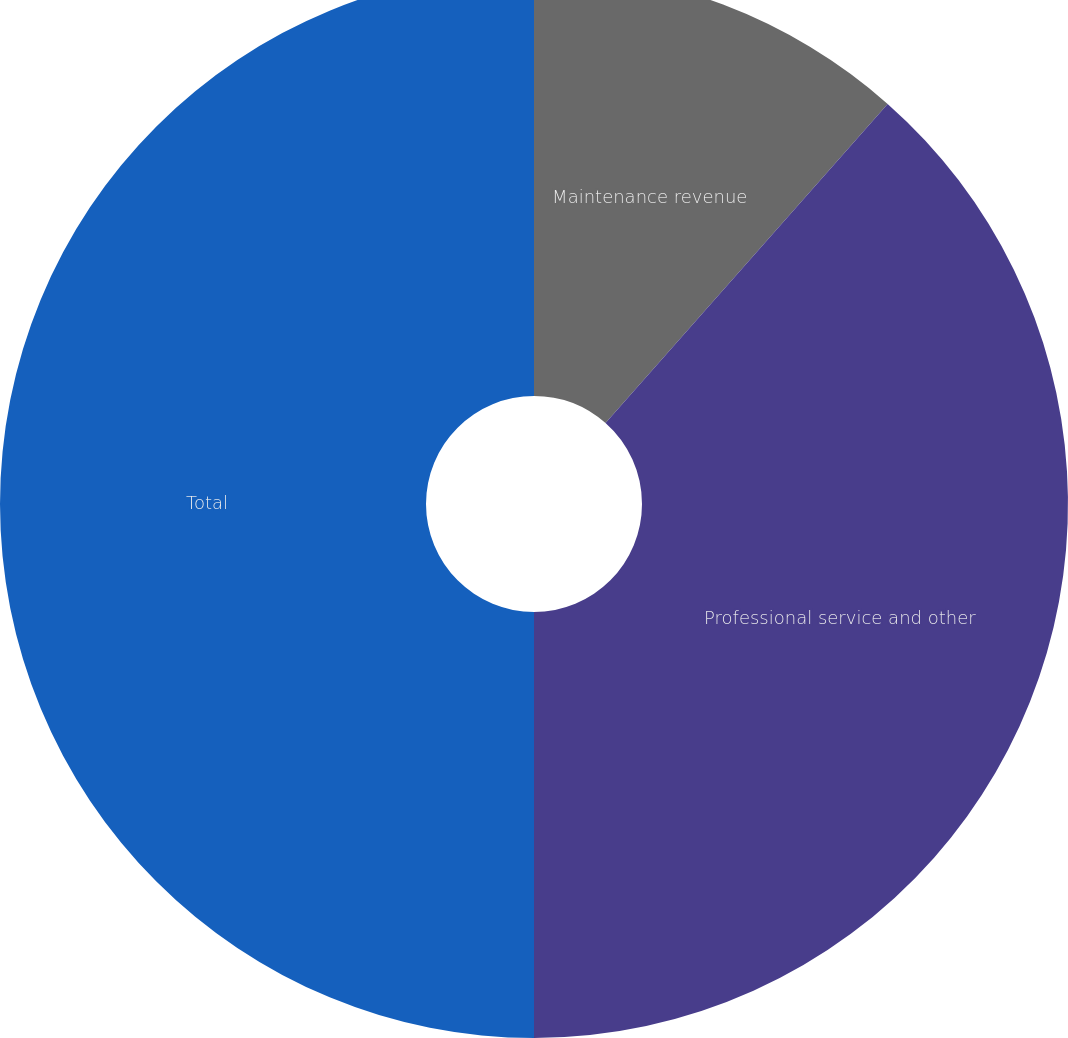Convert chart to OTSL. <chart><loc_0><loc_0><loc_500><loc_500><pie_chart><fcel>Maintenance revenue<fcel>Professional service and other<fcel>Total<nl><fcel>11.52%<fcel>38.48%<fcel>50.0%<nl></chart> 